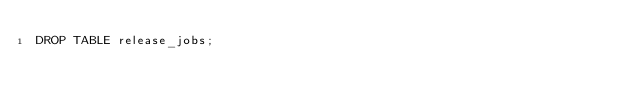Convert code to text. <code><loc_0><loc_0><loc_500><loc_500><_SQL_>DROP TABLE release_jobs;
</code> 